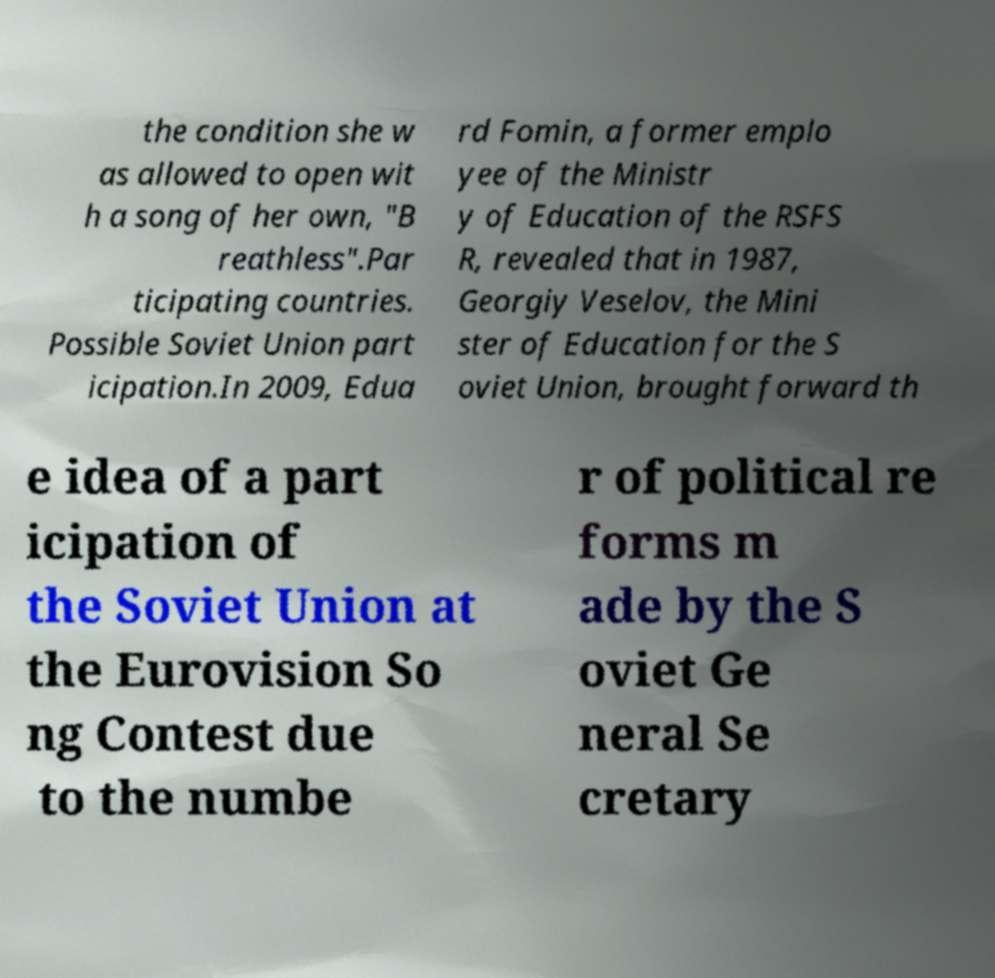For documentation purposes, I need the text within this image transcribed. Could you provide that? the condition she w as allowed to open wit h a song of her own, "B reathless".Par ticipating countries. Possible Soviet Union part icipation.In 2009, Edua rd Fomin, a former emplo yee of the Ministr y of Education of the RSFS R, revealed that in 1987, Georgiy Veselov, the Mini ster of Education for the S oviet Union, brought forward th e idea of a part icipation of the Soviet Union at the Eurovision So ng Contest due to the numbe r of political re forms m ade by the S oviet Ge neral Se cretary 